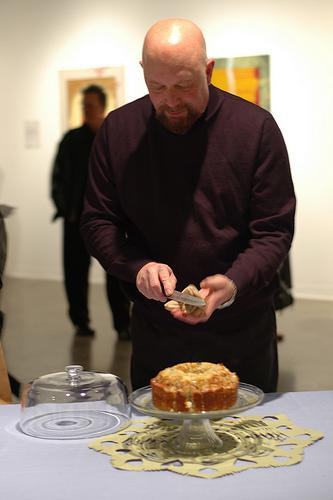Question: where was the picture taken?
Choices:
A. In a nightclub.
B. In a house.
C. In a ditch.
D. In an art gallery.
Answer with the letter. Answer: D Question: who is in the picture?
Choices:
A. Three women.
B. Two men.
C. Five boys.
D. A girl.
Answer with the letter. Answer: B Question: when was the picture taken?
Choices:
A. While the man was wiping a knife.
B. In the morning.
C. While the man was showering.
D. While the man was polishing his shoe.
Answer with the letter. Answer: A Question: what is the man doing?
Choices:
A. Polishing a shoe.
B. Eating with a fork.
C. Wiping a knife.
D. Cutting cabbage.
Answer with the letter. Answer: C Question: what is on the table?
Choices:
A. A pie.
B. A cupcake.
C. A cake.
D. A souffle.
Answer with the letter. Answer: C 